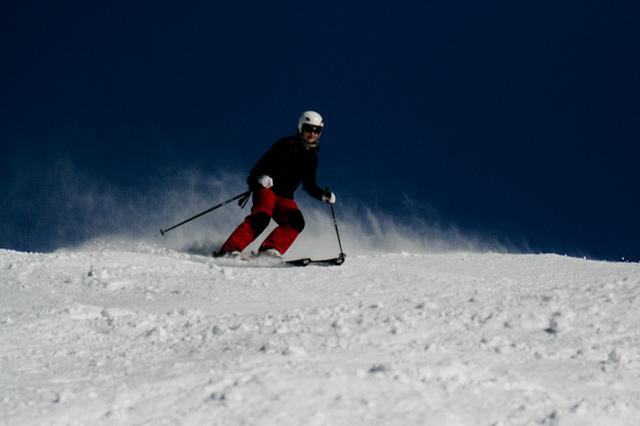Is he moving quickly?
Write a very short answer. Yes. Does he have on safety gear?
Give a very brief answer. Yes. What is on the ground?
Quick response, please. Snow. 